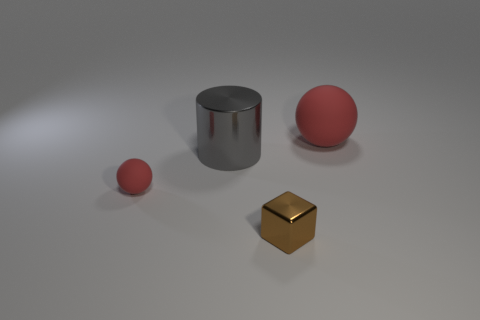How many small rubber balls are on the right side of the object that is to the left of the big metal cylinder?
Provide a succinct answer. 0. What is the color of the other rubber object that is the same size as the gray thing?
Offer a very short reply. Red. What is the red ball that is left of the large red matte thing made of?
Your answer should be compact. Rubber. What is the material of the thing that is both behind the tiny sphere and on the left side of the tiny brown shiny block?
Ensure brevity in your answer.  Metal. There is a rubber object to the right of the metallic cylinder; is it the same size as the tiny brown object?
Keep it short and to the point. No. The small red thing has what shape?
Offer a very short reply. Sphere. What number of big red matte things have the same shape as the tiny metal object?
Keep it short and to the point. 0. What number of red matte things are on the left side of the big gray shiny cylinder and on the right side of the gray cylinder?
Keep it short and to the point. 0. The big ball is what color?
Offer a very short reply. Red. Is there another brown cube made of the same material as the small brown block?
Give a very brief answer. No. 